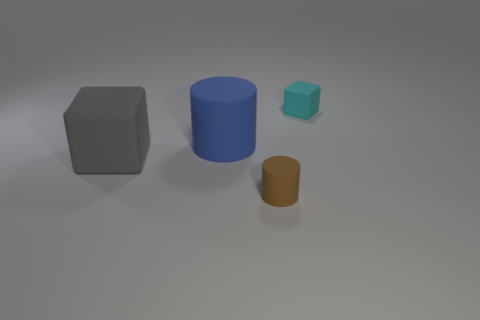Subtract 1 cylinders. How many cylinders are left? 1 Add 3 tiny brown cylinders. How many tiny brown cylinders are left? 4 Add 4 large yellow spheres. How many large yellow spheres exist? 4 Add 1 small matte blocks. How many objects exist? 5 Subtract all brown cylinders. How many cylinders are left? 1 Subtract 0 cyan balls. How many objects are left? 4 Subtract all cyan cubes. Subtract all yellow spheres. How many cubes are left? 1 Subtract all yellow balls. How many gray cubes are left? 1 Subtract all yellow metallic blocks. Subtract all big blocks. How many objects are left? 3 